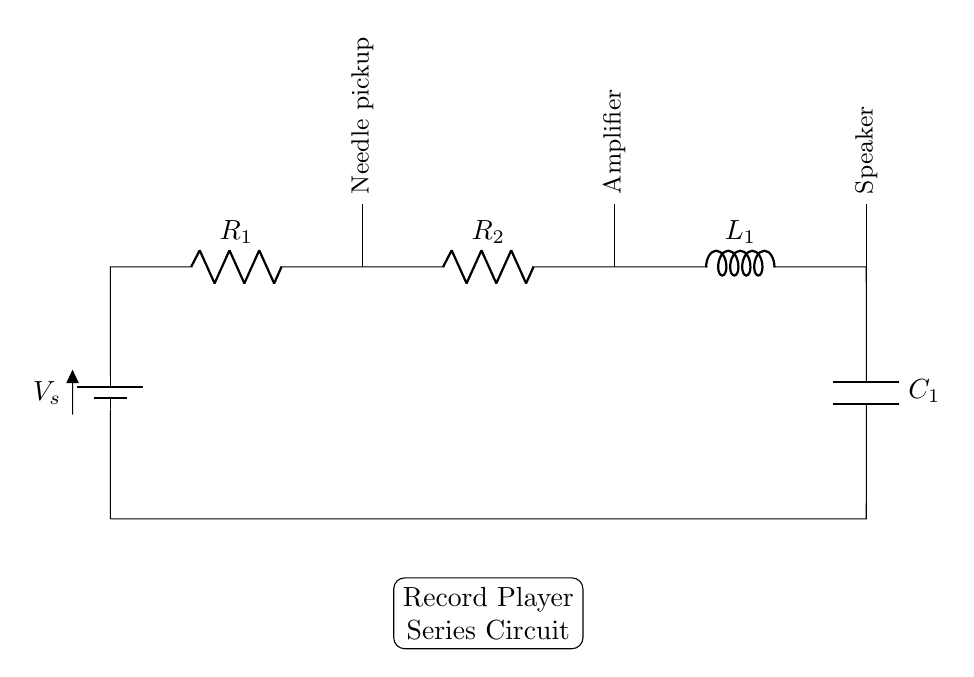What is the total number of components in this circuit? The total number of components includes the battery, two resistors, one inductor, one capacitor, one needle pickup, one amplifier, and one speaker. Counting these gives a total of seven components.
Answer: seven What type of circuit is shown in this diagram? This circuit is a series circuit because all components are connected end-to-end in a single path for current flow. In a series configuration, the same current flows through each component.
Answer: series What component is connected to the battery? The first component directly connected to the battery in the chain is the resistor labeled R1. It is the first element receiving the voltage from the battery, allowing current to flow into the circuit.
Answer: R1 What is the role of the needle pickup in the circuit? The needle pickup converts the mechanical vibrations from the record into electrical signals, which are then fed into the amplifier in the circuit for processing. It is the initial component capturing sound.
Answer: convert sound How many resistors are present in the circuit? There are two resistors in the circuit, labeled R1 and R2. Each provides resistance to the flow of current in the series configuration and affects the overall resistance of the circuit.
Answer: two What happens to the current in a series circuit as it passes through each component? In a series circuit, the current remains constant throughout; however, the voltage across each component may vary depending on its resistance or reactance. This is a defining characteristic of series circuits, as current doesn't branch or divide.
Answer: constant Which component is closest to the last in the series? The last component in the series as shown in the diagram is the capacitor labeled C1. It is positioned at the bottom end of the circuit and closes the loop back to the battery while influencing the timing characteristics of the circuit.
Answer: C1 